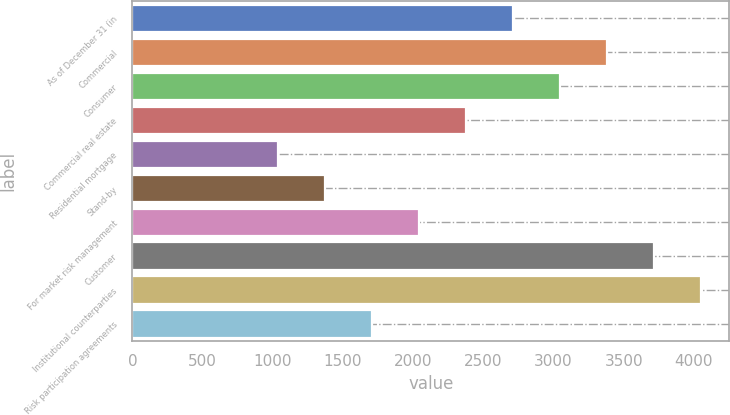Convert chart. <chart><loc_0><loc_0><loc_500><loc_500><bar_chart><fcel>As of December 31 (in<fcel>Commercial<fcel>Consumer<fcel>Commercial real estate<fcel>Residential mortgage<fcel>Stand-by<fcel>For market risk management<fcel>Customer<fcel>Institutional counterparties<fcel>Risk participation agreements<nl><fcel>2711.22<fcel>3380.2<fcel>3045.71<fcel>2376.73<fcel>1038.77<fcel>1373.26<fcel>2042.24<fcel>3714.69<fcel>4049.18<fcel>1707.75<nl></chart> 